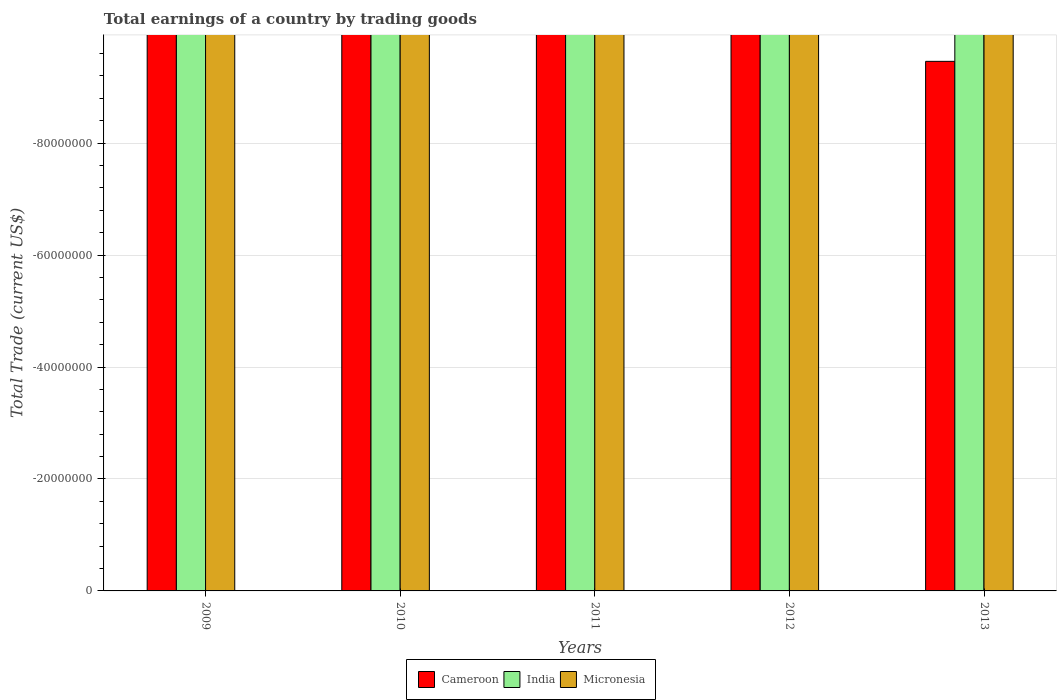Are the number of bars on each tick of the X-axis equal?
Give a very brief answer. Yes. How many bars are there on the 1st tick from the left?
Keep it short and to the point. 0. How many bars are there on the 3rd tick from the right?
Provide a short and direct response. 0. What is the total earnings in Cameroon in 2010?
Your answer should be compact. 0. Across all years, what is the minimum total earnings in Cameroon?
Offer a very short reply. 0. What is the total total earnings in Cameroon in the graph?
Provide a short and direct response. 0. What is the difference between the total earnings in Cameroon in 2012 and the total earnings in Micronesia in 2013?
Your answer should be very brief. 0. What is the average total earnings in India per year?
Give a very brief answer. 0. In how many years, is the total earnings in Cameroon greater than -16000000 US$?
Keep it short and to the point. 0. Is it the case that in every year, the sum of the total earnings in Cameroon and total earnings in Micronesia is greater than the total earnings in India?
Keep it short and to the point. No. Are all the bars in the graph horizontal?
Provide a short and direct response. No. Does the graph contain any zero values?
Give a very brief answer. Yes. Does the graph contain grids?
Offer a very short reply. Yes. Where does the legend appear in the graph?
Provide a succinct answer. Bottom center. How many legend labels are there?
Provide a short and direct response. 3. How are the legend labels stacked?
Make the answer very short. Horizontal. What is the title of the graph?
Provide a succinct answer. Total earnings of a country by trading goods. What is the label or title of the Y-axis?
Your answer should be compact. Total Trade (current US$). What is the Total Trade (current US$) in Micronesia in 2009?
Offer a terse response. 0. What is the Total Trade (current US$) of Cameroon in 2010?
Give a very brief answer. 0. What is the Total Trade (current US$) in Cameroon in 2011?
Keep it short and to the point. 0. What is the Total Trade (current US$) in India in 2011?
Offer a very short reply. 0. What is the Total Trade (current US$) in Micronesia in 2011?
Offer a very short reply. 0. What is the Total Trade (current US$) in India in 2012?
Give a very brief answer. 0. What is the Total Trade (current US$) of Micronesia in 2012?
Make the answer very short. 0. What is the average Total Trade (current US$) in India per year?
Your answer should be compact. 0. 